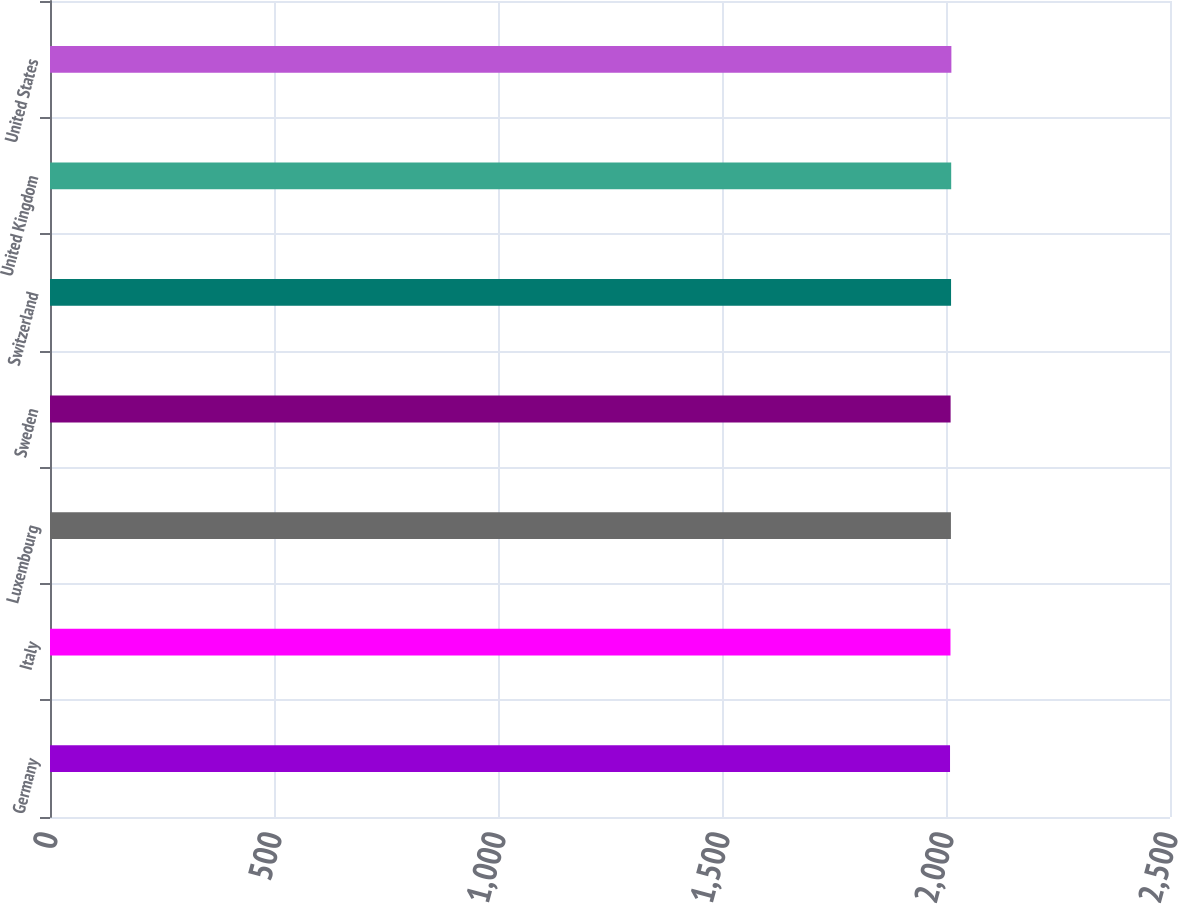<chart> <loc_0><loc_0><loc_500><loc_500><bar_chart><fcel>Germany<fcel>Italy<fcel>Luxembourg<fcel>Sweden<fcel>Switzerland<fcel>United Kingdom<fcel>United States<nl><fcel>2009<fcel>2010<fcel>2011<fcel>2010.3<fcel>2011.3<fcel>2011.6<fcel>2012<nl></chart> 